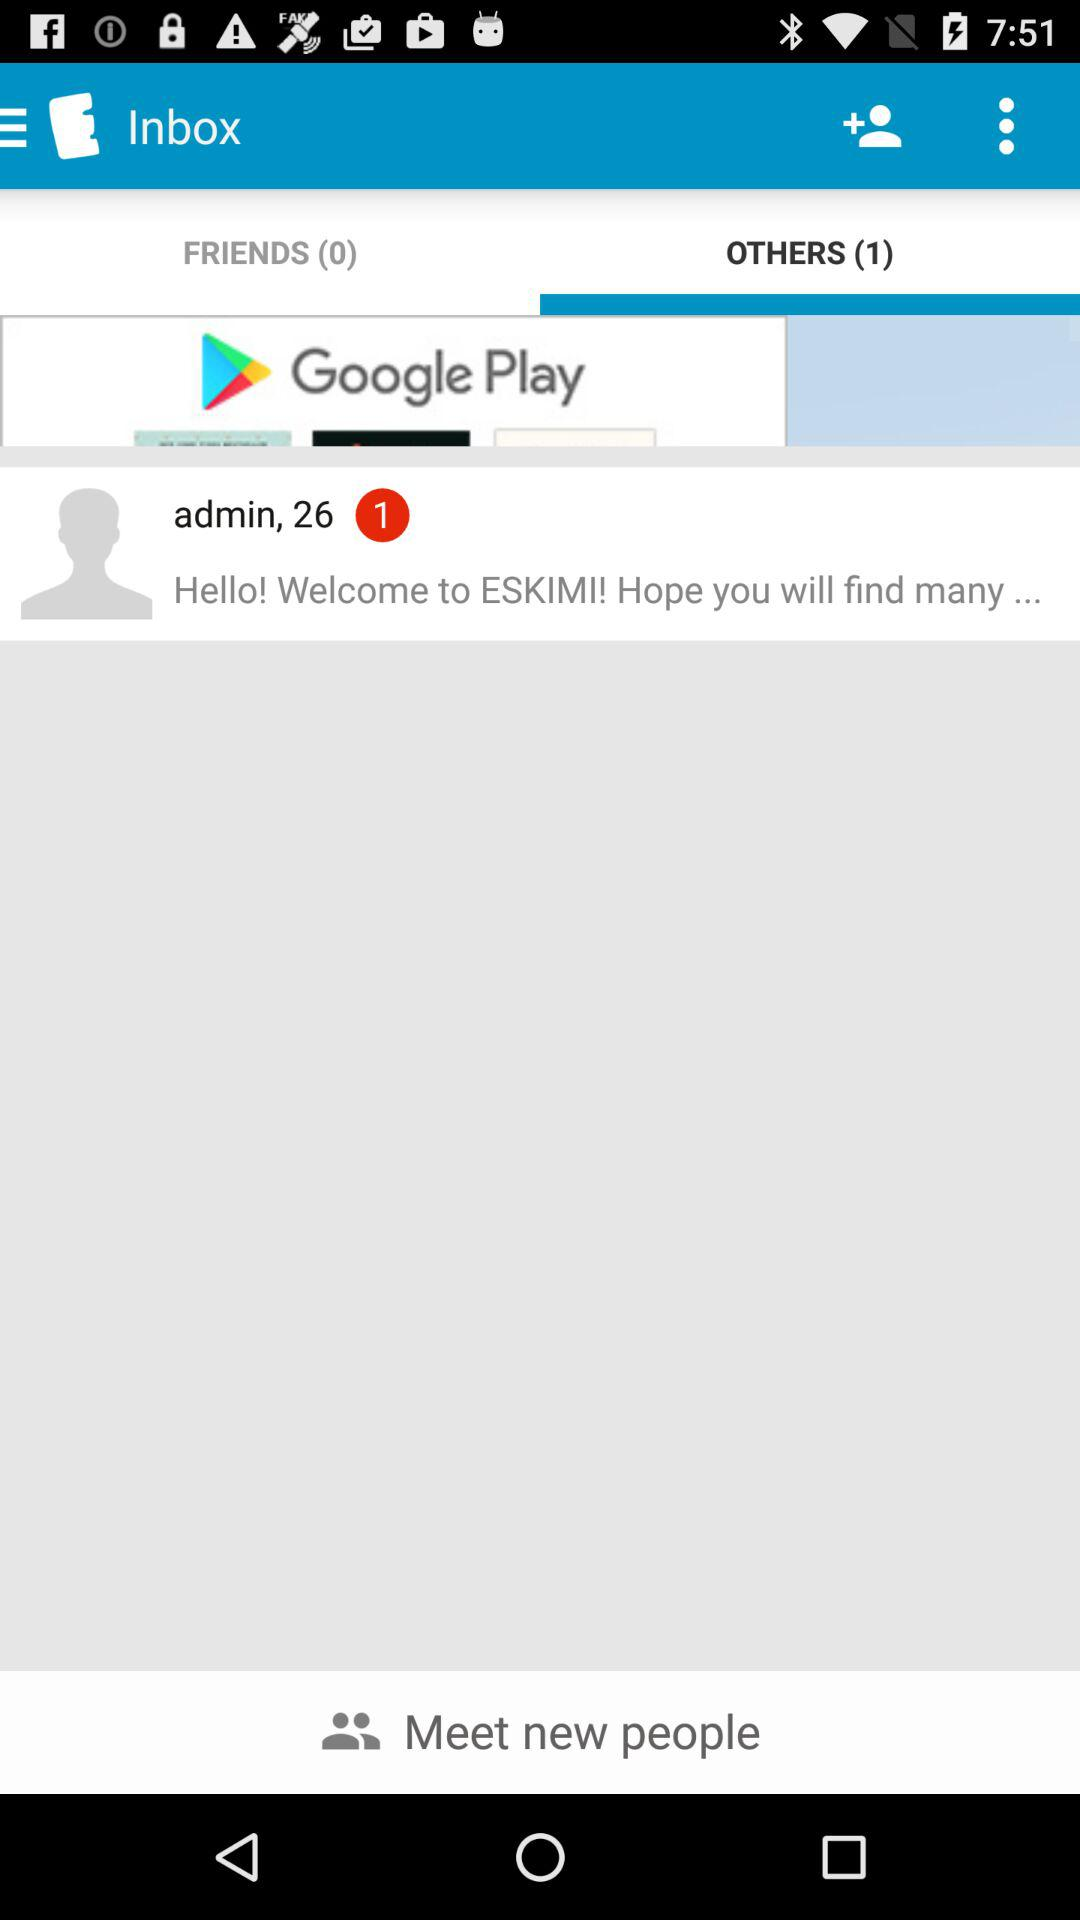What is the age of the admin? The admin is 26 years old. 